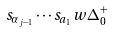<formula> <loc_0><loc_0><loc_500><loc_500>s _ { \alpha _ { j - 1 } } \cdots s _ { a _ { 1 } } w \Delta _ { 0 } ^ { + }</formula> 